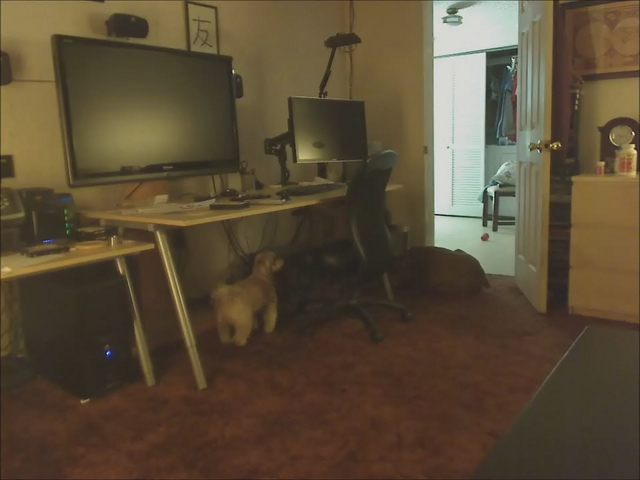<image>What has a triangle shape in the room? I don't know what has a triangle shape in the room. It could be table legs, a lamp, a desk, a laptop, or a shadow. What pattern is shown on the book bag? I am not sure about the pattern on the book bag. It could be solid, checkered, stripe or no pattern at all. What has a triangle shape in the room? I don't know if there is anything with a triangle shape in the room. It could be table legs, lamp, desk, or shadow. What pattern is shown on the book bag? I don't know what pattern is shown on the book bag. It can be solid, checkered, striped, or have no pattern. 